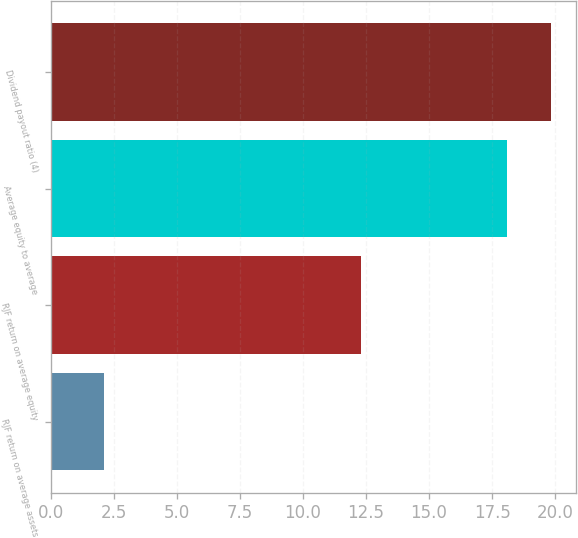Convert chart to OTSL. <chart><loc_0><loc_0><loc_500><loc_500><bar_chart><fcel>RJF return on average assets<fcel>RJF return on average equity<fcel>Average equity to average<fcel>Dividend payout ratio (4)<nl><fcel>2.1<fcel>12.3<fcel>18.1<fcel>19.82<nl></chart> 